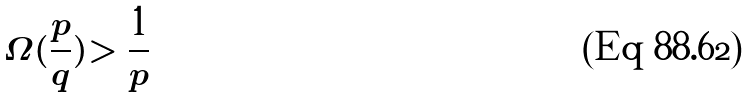<formula> <loc_0><loc_0><loc_500><loc_500>\Omega ( \frac { p } { q } ) > \frac { 1 } { p }</formula> 